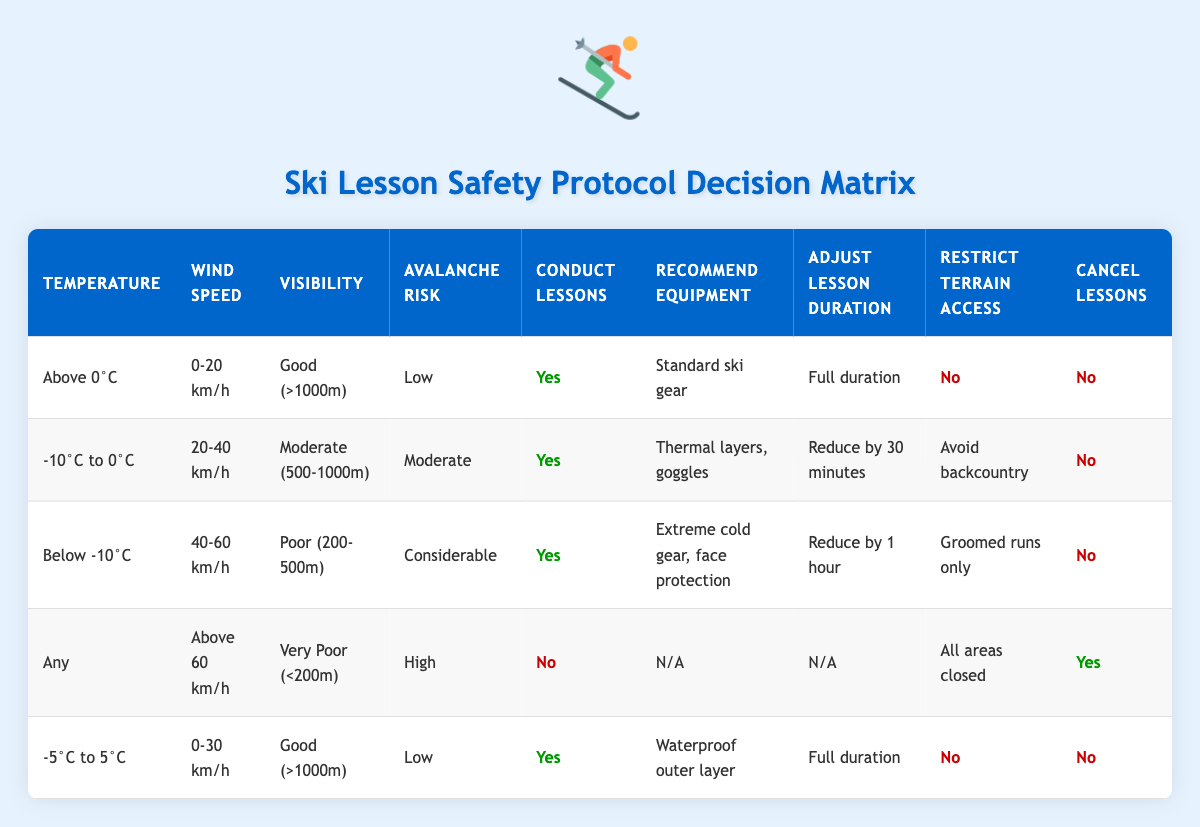What actions are recommended when the temperature is below -10°C? According to the table, if the temperature is below -10°C, the recommended equipment is "Extreme cold gear, face protection". The lessons are still conducted but the duration is reduced by 1 hour, and terrain access is restricted to groomed runs only.
Answer: Extreme cold gear, face protection What is the maximum wind speed allowed to conduct ski lessons when the visibility is good (>1000m)? The table shows that when visibility is good (>1000m), the corresponding wind speed for conducting lessons can be in the range of 0-20 km/h or 0-30 km/h if the temperature is between -5°C to 5°C. Therefore, the maximum wind speed allowed in these cases is 30 km/h.
Answer: 30 km/h If the avalanche risk is considerable, can lessons be conducted? The table indicates that if the avalanche risk is considerable, lessons can still be conducted despite the other unfavorable conditions. Hence, the answer to this question is yes.
Answer: Yes What is the terrain access restriction if the wind speed is above 60 km/h? The table explicitly states that if the wind speed exceeds 60 km/h, all areas are closed, which implies no terrain access is allowed.
Answer: All areas closed How many different wind speed ranges are identified in the table, and what are they? The table outlines four distinct wind speed ranges: 0-20 km/h, 20-40 km/h, 40-60 km/h, and above 60 km/h. Thus, the total number of identified ranges is four.
Answer: 4 What equipment is recommended when the temperature is between -10°C and 0°C? For temperatures between -10°C and 0°C, the table recommends using thermal layers and goggles as equipment for ski lessons.
Answer: Thermal layers, goggles In what scenario are lessons canceled? Lessons are canceled when the wind speed is above 60 km/h, accompanied by very poor visibility (<200m) and a high avalanche risk. This is detailed in the specific rule for these conditions.
Answer: Wind speed above 60 km/h, very poor visibility, high avalanche risk What is the average adjustment to lesson duration for the conditions listed? The adjustments to lesson duration across different rules are: full duration (0 minutes), reduce by 30 minutes, reduce by 1 hour (60 minutes), and not applicable when lessons are canceled. Calculating the sum gives the total adjustment: 0 + (-30) + (-60) + 0 = -90 minutes. Now, dividing by the 3 applicable adjustments gives an average of -30 minutes.
Answer: -30 minutes If the visibility is poor (200-500m), what is the copper of lesson cancellation? The table indicates that with poor visibility (200-500m), lessons can still be conducted according to the row for temperatures below -10°C. Therefore, the condition does not guarantee cancellation, making it false for this query.
Answer: No 